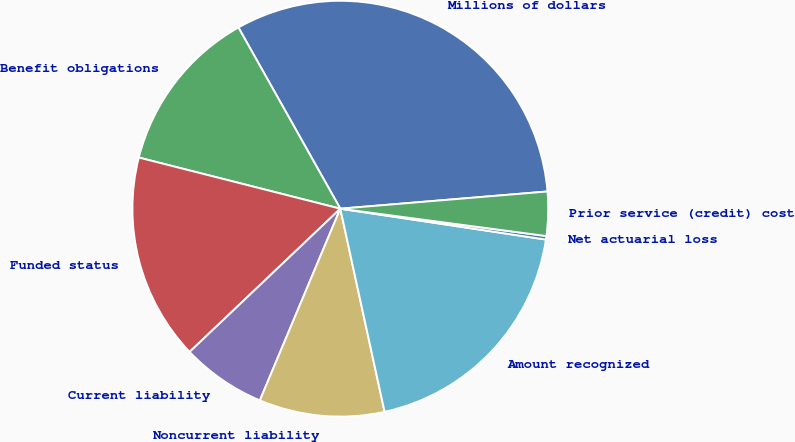Convert chart. <chart><loc_0><loc_0><loc_500><loc_500><pie_chart><fcel>Millions of dollars<fcel>Benefit obligations<fcel>Funded status<fcel>Current liability<fcel>Noncurrent liability<fcel>Amount recognized<fcel>Net actuarial loss<fcel>Prior service (credit) cost<nl><fcel>31.83%<fcel>12.89%<fcel>16.05%<fcel>6.58%<fcel>9.74%<fcel>19.21%<fcel>0.27%<fcel>3.42%<nl></chart> 